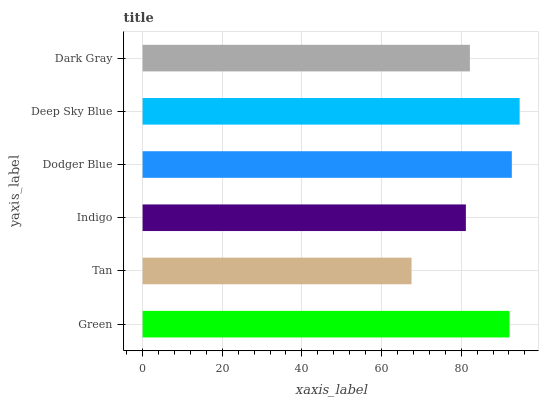Is Tan the minimum?
Answer yes or no. Yes. Is Deep Sky Blue the maximum?
Answer yes or no. Yes. Is Indigo the minimum?
Answer yes or no. No. Is Indigo the maximum?
Answer yes or no. No. Is Indigo greater than Tan?
Answer yes or no. Yes. Is Tan less than Indigo?
Answer yes or no. Yes. Is Tan greater than Indigo?
Answer yes or no. No. Is Indigo less than Tan?
Answer yes or no. No. Is Green the high median?
Answer yes or no. Yes. Is Dark Gray the low median?
Answer yes or no. Yes. Is Deep Sky Blue the high median?
Answer yes or no. No. Is Dodger Blue the low median?
Answer yes or no. No. 